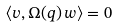<formula> <loc_0><loc_0><loc_500><loc_500>\langle v , \Omega ( q ) \, w \rangle = 0</formula> 